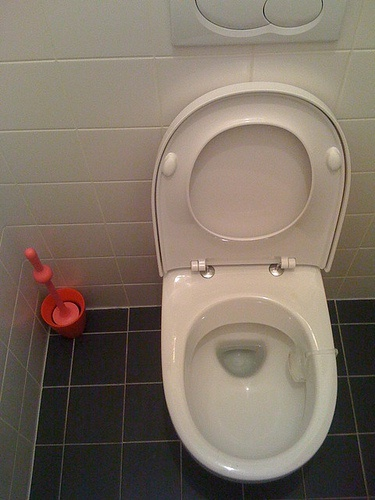Describe the objects in this image and their specific colors. I can see a toilet in gray, darkgray, and tan tones in this image. 